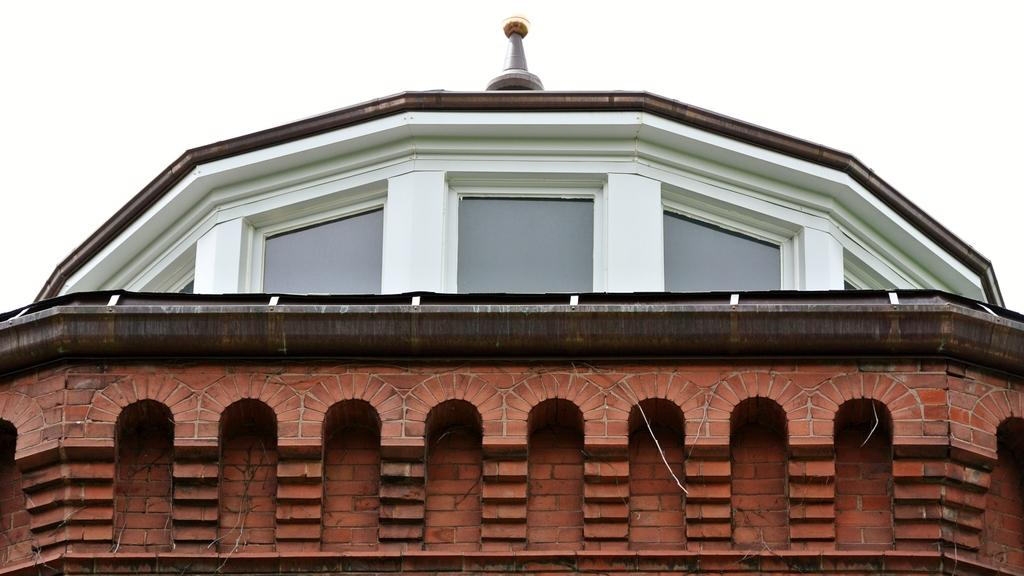What type of view is shown in the image? The image shows a top view of a building. What architectural feature can be seen on the building? There are windows visible on the building. How many cats can be seen playing with the boys in the image? There are no cats or boys present in the image; it shows a top view of a building with visible windows. 